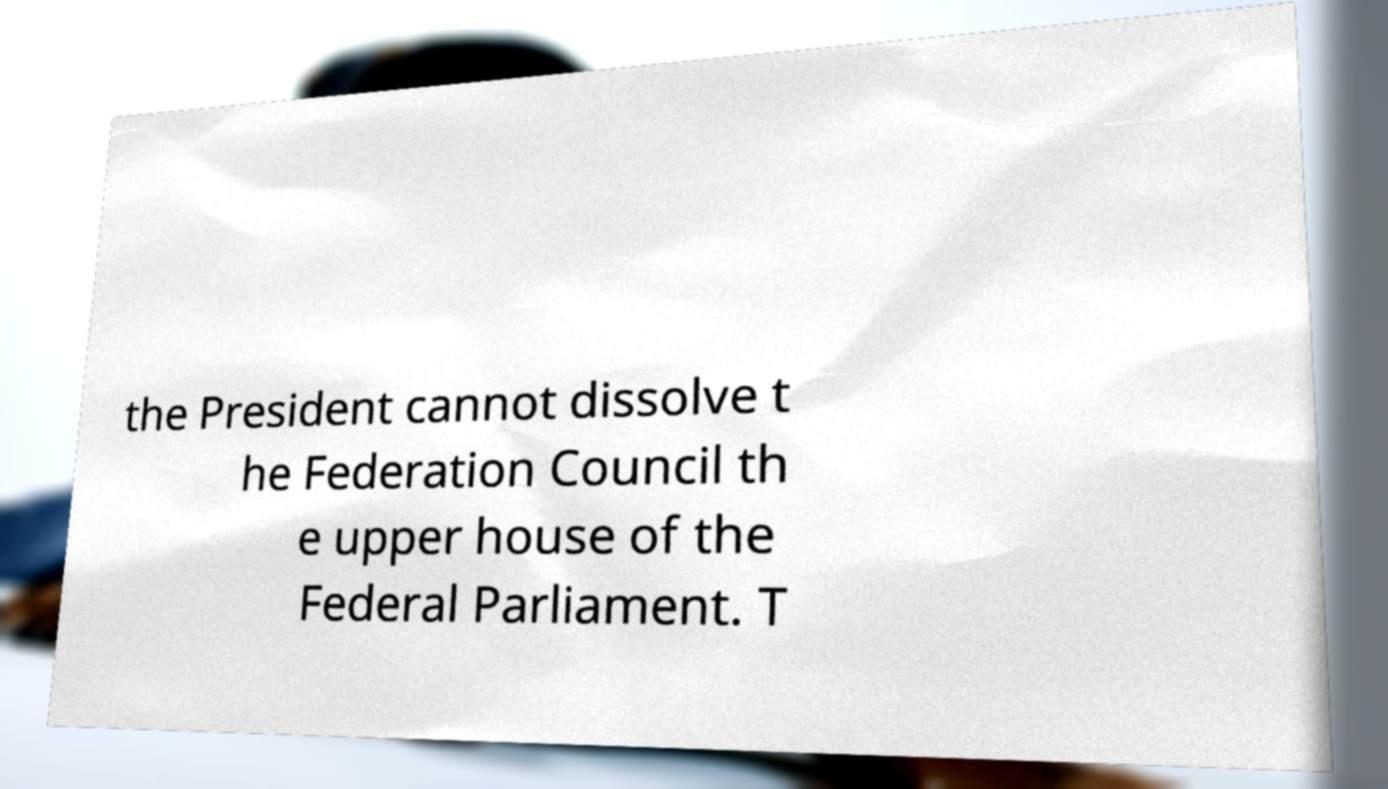Could you assist in decoding the text presented in this image and type it out clearly? the President cannot dissolve t he Federation Council th e upper house of the Federal Parliament. T 